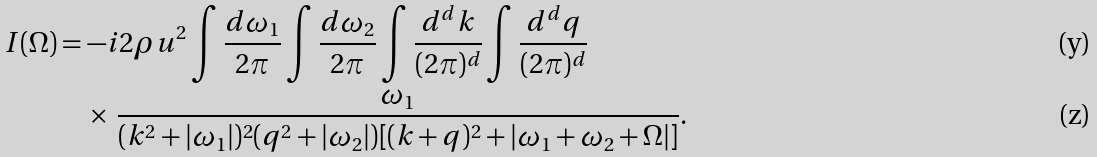<formula> <loc_0><loc_0><loc_500><loc_500>I ( \Omega ) & = - i 2 \rho u ^ { 2 } \int \frac { d \omega _ { 1 } } { 2 \pi } \int \frac { d \omega _ { 2 } } { 2 \pi } \int \frac { d ^ { d } k } { ( 2 \pi ) ^ { d } } \int \frac { d ^ { d } q } { ( 2 \pi ) ^ { d } } \\ & \quad \times \, \frac { \omega _ { 1 } } { ( k ^ { 2 } + | \omega _ { 1 } | ) ^ { 2 } ( q ^ { 2 } + | \omega _ { 2 } | ) [ ( k + q ) ^ { 2 } + | \omega _ { 1 } + \omega _ { 2 } + \Omega | ] } .</formula> 